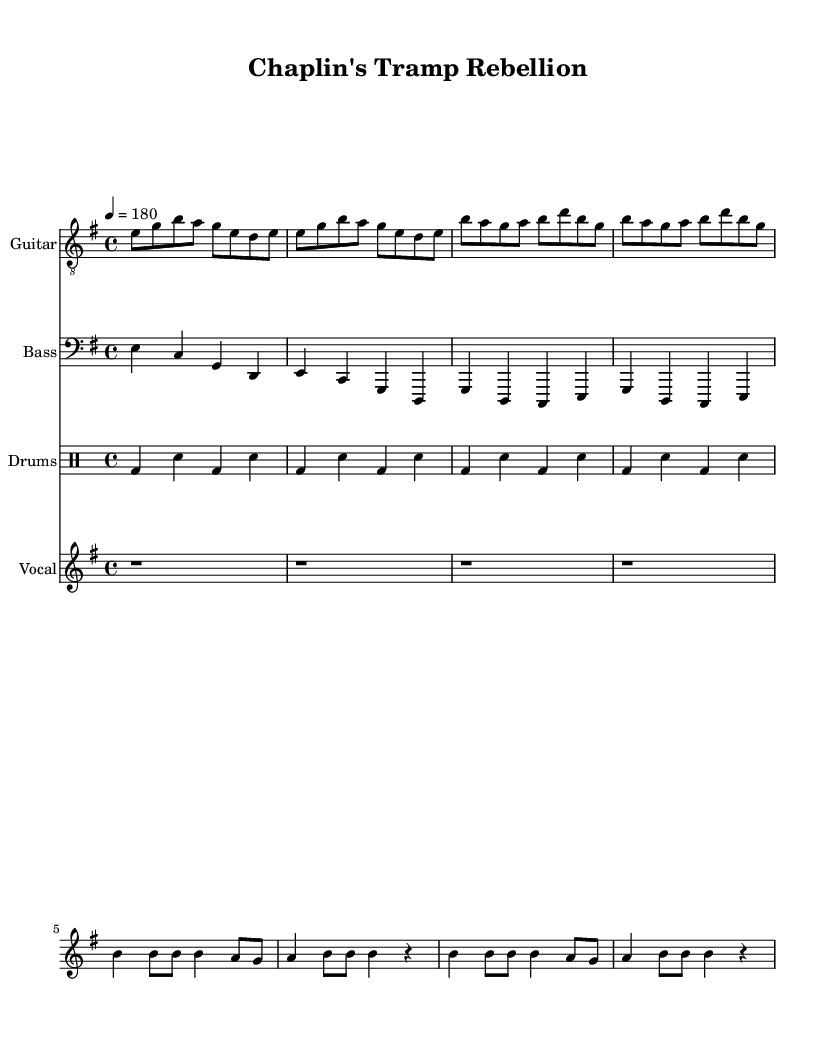What is the key signature of this music? The key signature is indicated at the beginning of the score. Here, it shows one sharp on the F line, which designates E minor.
Answer: E minor What is the time signature of this music? The time signature is displayed at the start of the sheet music and is indicated as 4/4, meaning there are four beats in a measure and a quarter note gets one beat.
Answer: 4/4 What is the tempo marking for this piece? The tempo marking near the top of the score states "4 = 180," which means there are 180 beats per minute in a quarter-note pulse.
Answer: 180 How many measures are in the verse section? The verse section consists of two melodic phrases, each repeated once, making a total of four measures (two measures repeated twice).
Answer: 4 What type of drum pattern is used in this piece? The drum pattern follows a typical punk rock beat, characterized by bass drum and snare alternation. In the provided drumming notation, you can see a standard punk beat structure with bass and snare hits.
Answer: Standard punk beat What vocal rhythm is used during the chorus? In the chorus, the vocals alternate between quarter notes and eighth notes, contributing to a dynamic rhythmic structure common in punk music. The specific notation illustrates this variety.
Answer: Varied (quarter and eighth notes) How does this piece pay tribute to Charlie Chaplin? The lyrics refer to Charlie Chaplin, mentioning him explicitly in the chorus as "king of silent screens," which directly connects the music to his legacy in silent film.
Answer: Tribute to Chaplin 